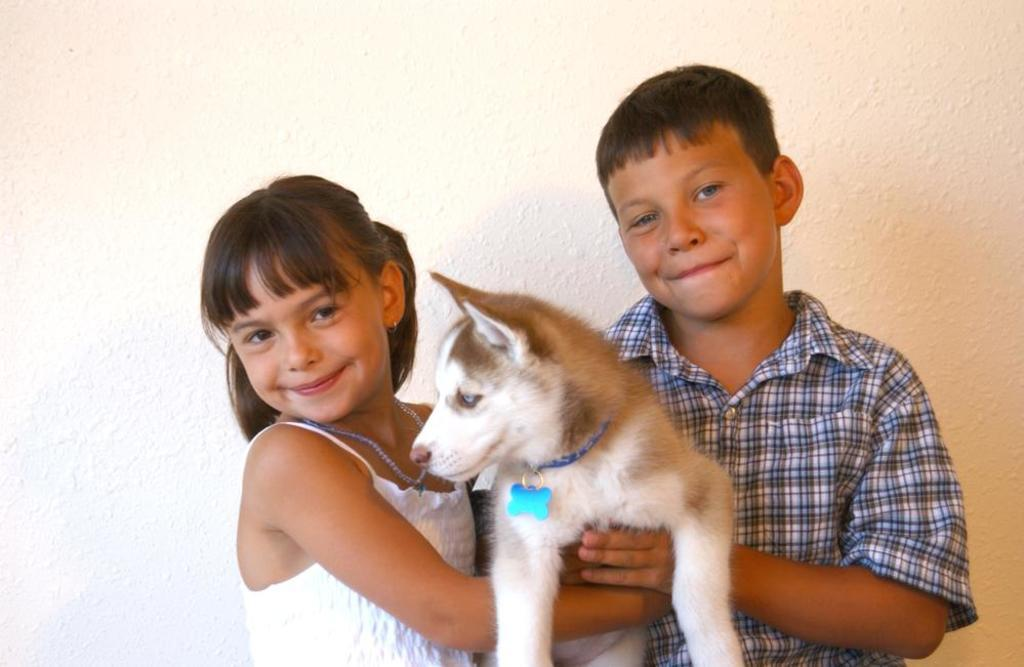Who is present in the image? There is a boy and a girl in the image. What are the boy and girl doing in the image? Both the boy and girl are holding a dog and smiling. What can be seen in the background of the image? There is a wall in the background of the image. What type of wool is the dog wearing in the image? There is no wool present in the image, nor is the dog wearing any clothing. 